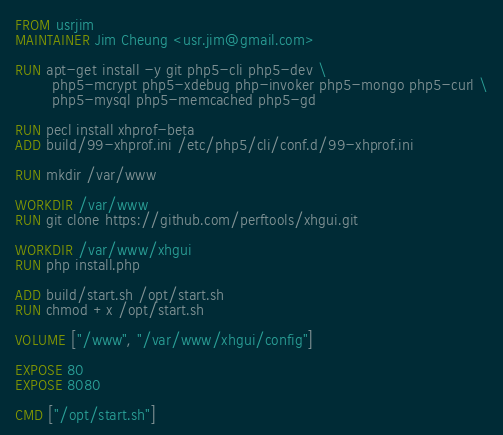Convert code to text. <code><loc_0><loc_0><loc_500><loc_500><_Dockerfile_>FROM usrjim
MAINTAINER Jim Cheung <usr.jim@gmail.com>

RUN apt-get install -y git php5-cli php5-dev \
        php5-mcrypt php5-xdebug php-invoker php5-mongo php5-curl \
        php5-mysql php5-memcached php5-gd

RUN pecl install xhprof-beta
ADD build/99-xhprof.ini /etc/php5/cli/conf.d/99-xhprof.ini

RUN mkdir /var/www

WORKDIR /var/www
RUN git clone https://github.com/perftools/xhgui.git

WORKDIR /var/www/xhgui
RUN php install.php

ADD build/start.sh /opt/start.sh
RUN chmod +x /opt/start.sh

VOLUME ["/www", "/var/www/xhgui/config"]

EXPOSE 80
EXPOSE 8080

CMD ["/opt/start.sh"]

</code> 